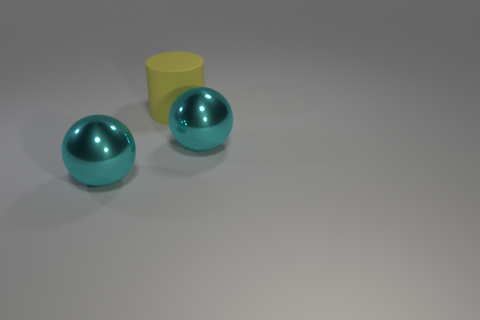Add 2 big gray rubber blocks. How many objects exist? 5 Subtract all cylinders. How many objects are left? 2 Add 3 big blue shiny cylinders. How many big blue shiny cylinders exist? 3 Subtract 0 red cylinders. How many objects are left? 3 Subtract all spheres. Subtract all yellow matte cylinders. How many objects are left? 0 Add 1 rubber objects. How many rubber objects are left? 2 